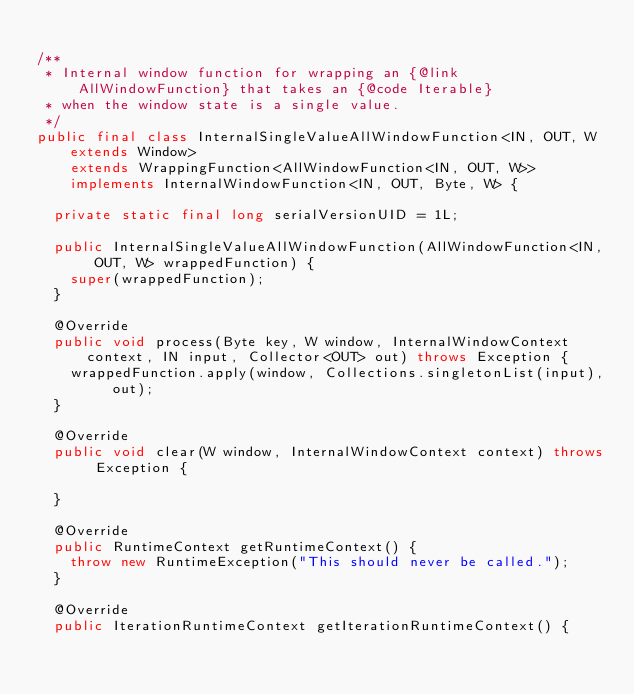Convert code to text. <code><loc_0><loc_0><loc_500><loc_500><_Java_>
/**
 * Internal window function for wrapping an {@link AllWindowFunction} that takes an {@code Iterable}
 * when the window state is a single value.
 */
public final class InternalSingleValueAllWindowFunction<IN, OUT, W extends Window>
		extends WrappingFunction<AllWindowFunction<IN, OUT, W>>
		implements InternalWindowFunction<IN, OUT, Byte, W> {

	private static final long serialVersionUID = 1L;

	public InternalSingleValueAllWindowFunction(AllWindowFunction<IN, OUT, W> wrappedFunction) {
		super(wrappedFunction);
	}

	@Override
	public void process(Byte key, W window, InternalWindowContext context, IN input, Collector<OUT> out) throws Exception {
		wrappedFunction.apply(window, Collections.singletonList(input), out);
	}

	@Override
	public void clear(W window, InternalWindowContext context) throws Exception {

	}

	@Override
	public RuntimeContext getRuntimeContext() {
		throw new RuntimeException("This should never be called.");
	}

	@Override
	public IterationRuntimeContext getIterationRuntimeContext() {</code> 